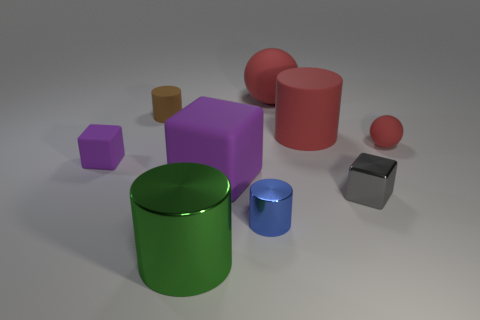Subtract all brown cylinders. Subtract all purple balls. How many cylinders are left? 3 Add 1 tiny metal cubes. How many objects exist? 10 Subtract all cylinders. How many objects are left? 5 Subtract 0 blue blocks. How many objects are left? 9 Subtract all cylinders. Subtract all large red cylinders. How many objects are left? 4 Add 2 big purple rubber cubes. How many big purple rubber cubes are left? 3 Add 9 big green things. How many big green things exist? 10 